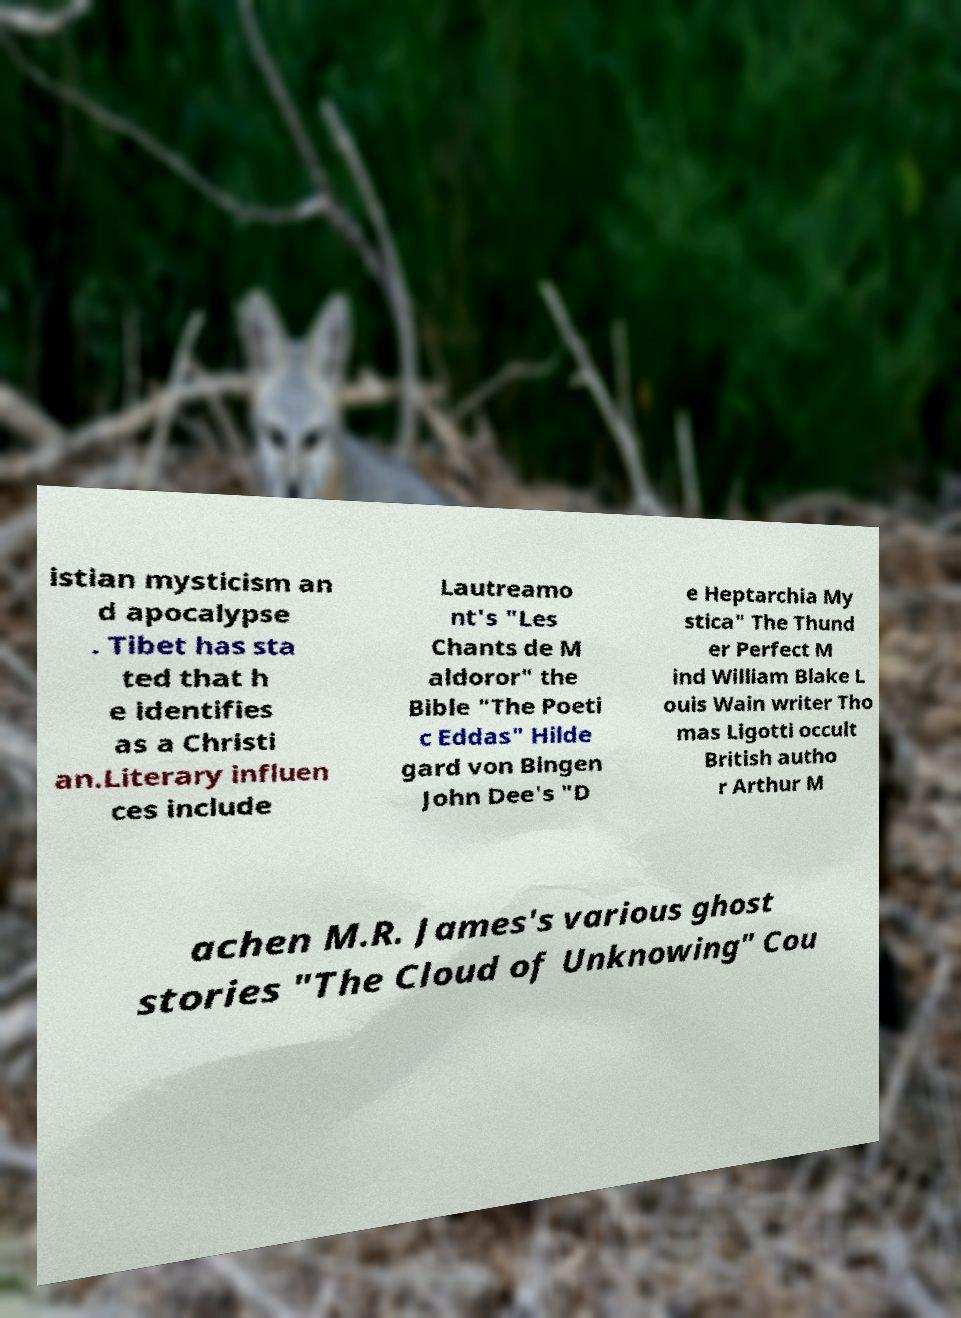Can you read and provide the text displayed in the image?This photo seems to have some interesting text. Can you extract and type it out for me? istian mysticism an d apocalypse . Tibet has sta ted that h e identifies as a Christi an.Literary influen ces include Lautreamo nt's "Les Chants de M aldoror" the Bible "The Poeti c Eddas" Hilde gard von Bingen John Dee's "D e Heptarchia My stica" The Thund er Perfect M ind William Blake L ouis Wain writer Tho mas Ligotti occult British autho r Arthur M achen M.R. James's various ghost stories "The Cloud of Unknowing" Cou 